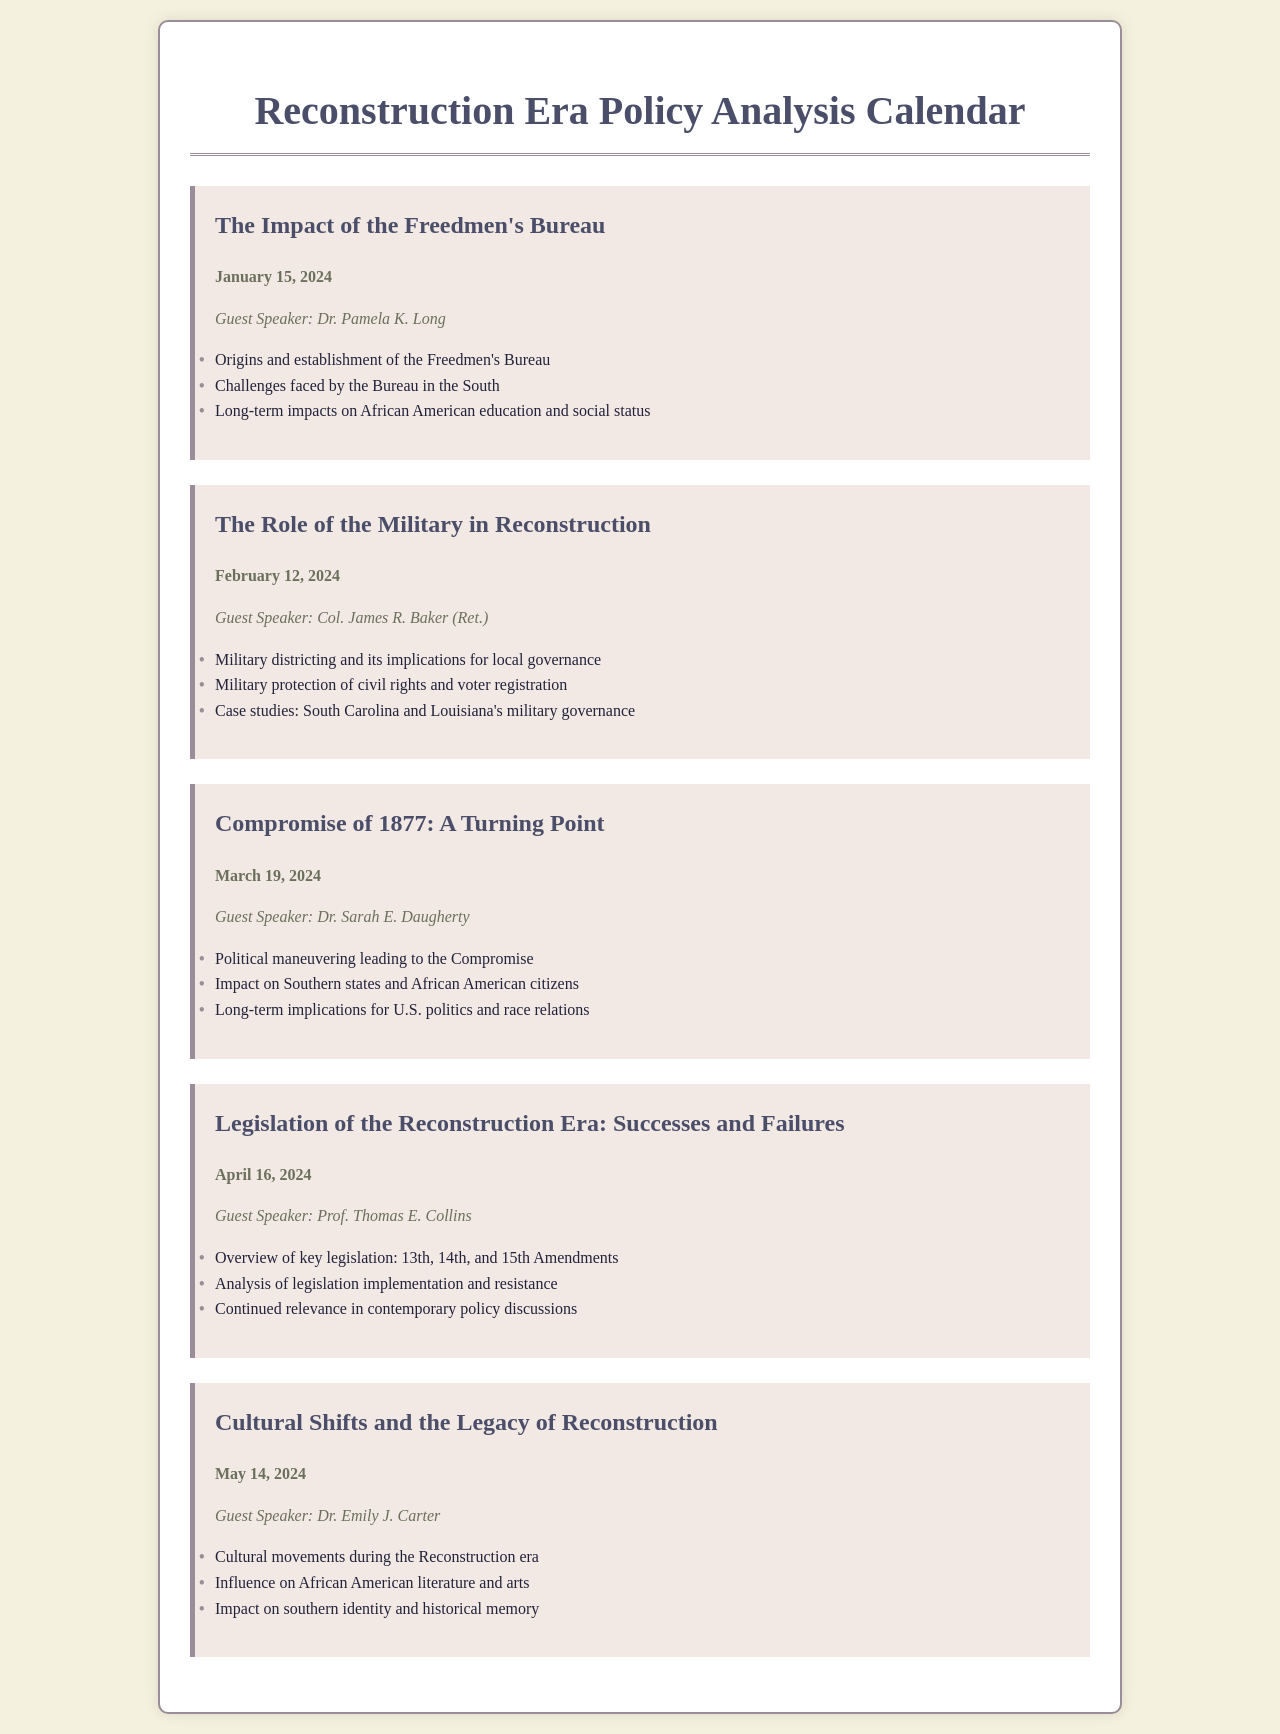What is the date of the seminar on the Freedmen's Bureau? The date is provided next to the seminar title for the Freedmen's Bureau discussion.
Answer: January 15, 2024 Who is the guest speaker for the seminar on the Compromise of 1877? The guest speaker is listed below the seminar title and date for the Compromise of 1877.
Answer: Dr. Sarah E. Daugherty What are the key amendments discussed in the seminar about Reconstruction Era legislation? The amendments are specifically mentioned in the overview of key legislation within this seminar.
Answer: 13th, 14th, and 15th Amendments What topic will Dr. Emily J. Carter discuss in May 2024? The topic is stated under the seminar header for the session with Dr. Emily J. Carter.
Answer: Cultural Shifts and the Legacy of Reconstruction Which state's military governance is included in the seminar on the Role of the Military in Reconstruction? This information is provided in a case study context within the seminar topics listed.
Answer: South Carolina What is the main focus of the seminar scheduled for April 16, 2024? The focus is usually articulated in the title and overview provided for each seminar.
Answer: Successes and Failures What is the color scheme of the document background? The color scheme can be inferred from the styles defined in the HTML.
Answer: Light cream How many seminars are scheduled in this calendar? The number of scheduled seminars can be counted in the document.
Answer: Five 